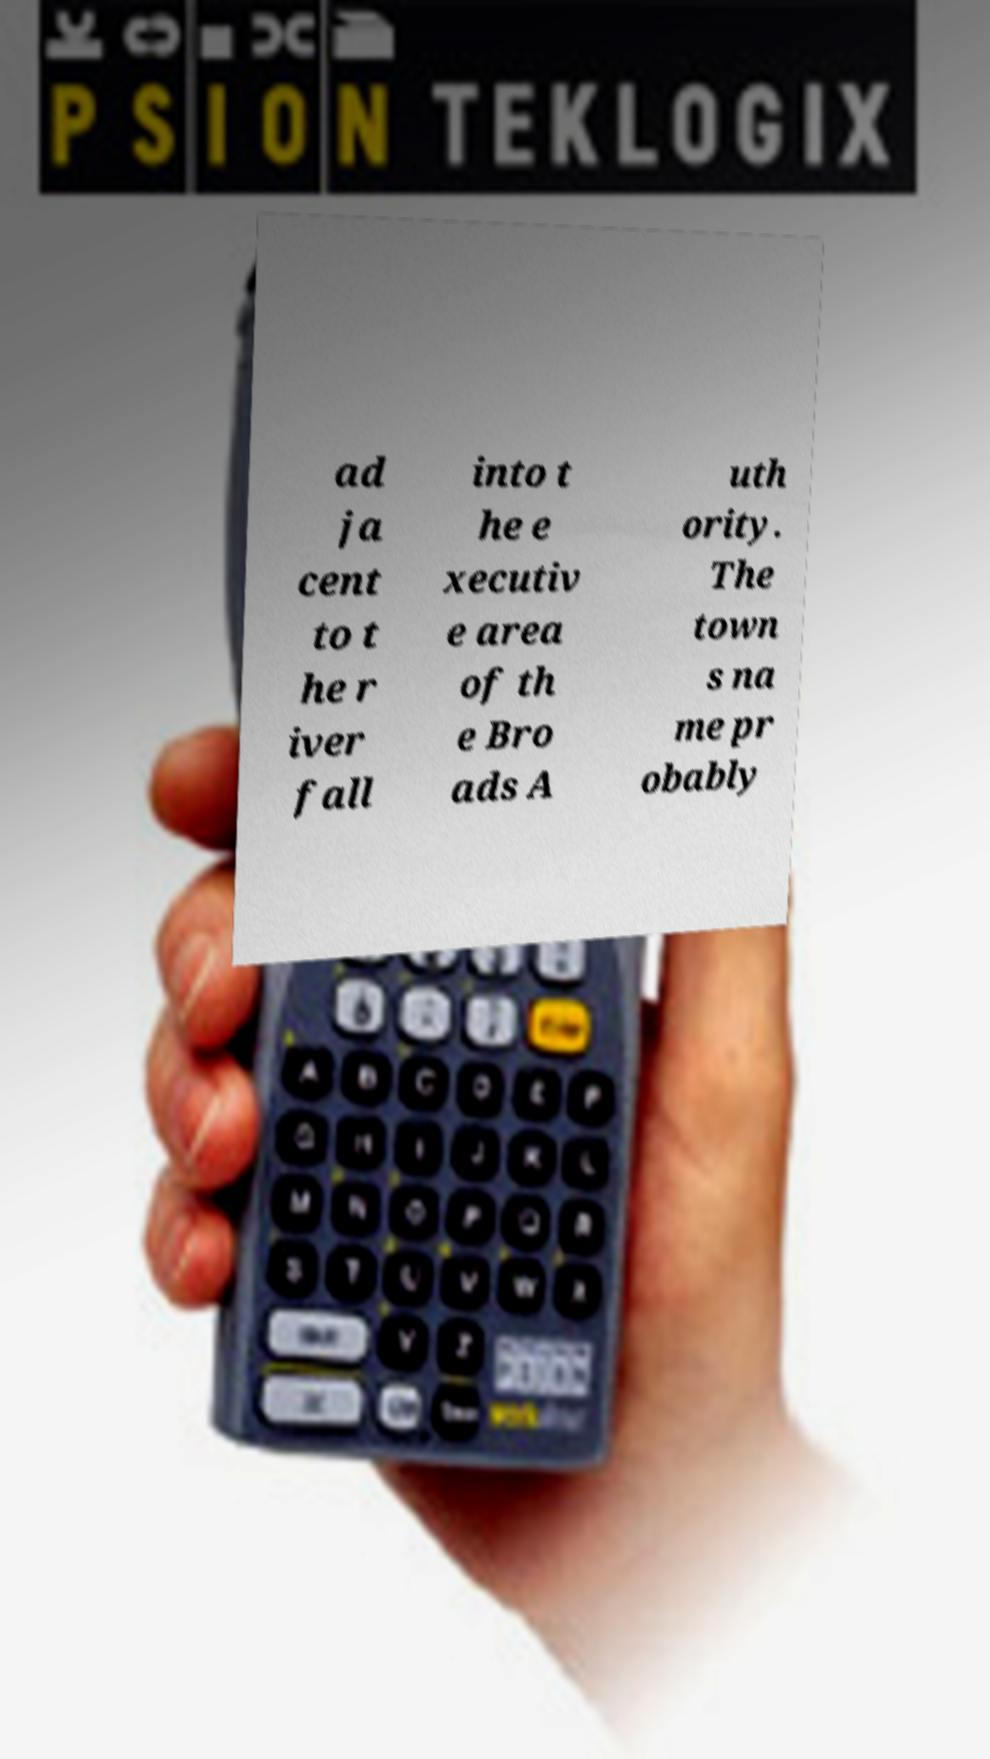Can you read and provide the text displayed in the image?This photo seems to have some interesting text. Can you extract and type it out for me? ad ja cent to t he r iver fall into t he e xecutiv e area of th e Bro ads A uth ority. The town s na me pr obably 